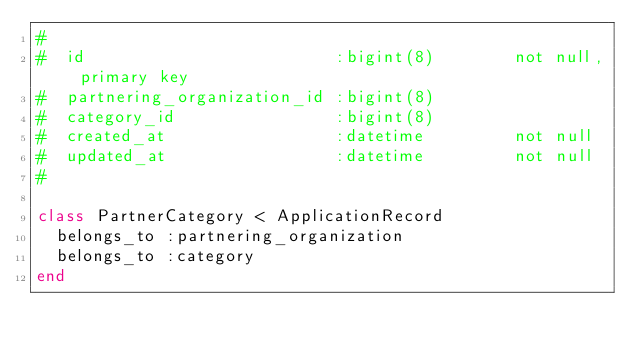Convert code to text. <code><loc_0><loc_0><loc_500><loc_500><_Ruby_>#
#  id                         :bigint(8)        not null, primary key
#  partnering_organization_id :bigint(8)
#  category_id                :bigint(8)
#  created_at                 :datetime         not null
#  updated_at                 :datetime         not null
#

class PartnerCategory < ApplicationRecord
  belongs_to :partnering_organization
  belongs_to :category
end
</code> 